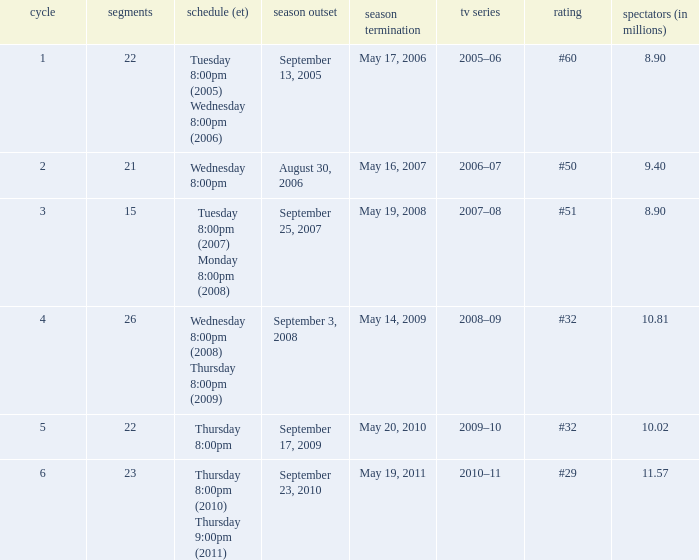In how many seasons was the position equivalent to #50? 1.0. 